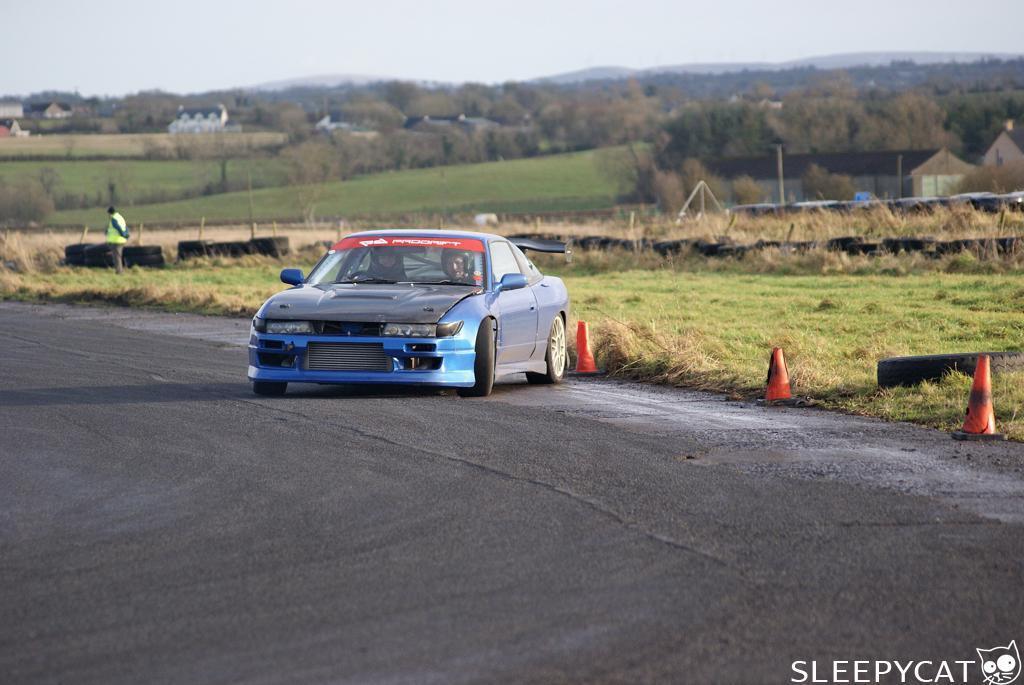Could you give a brief overview of what you see in this image? This is the picture of a road. In this image there is a car on the road and there are two persons sitting inside the car. At the back there are buildings, trees and poles and mountains. On the left side of the image there is a person standing on the road. At the top there is sky. At the bottom there is a road. 